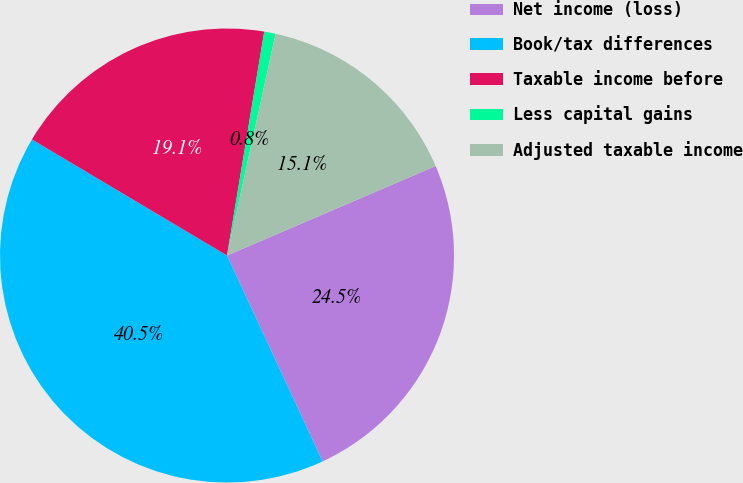Convert chart to OTSL. <chart><loc_0><loc_0><loc_500><loc_500><pie_chart><fcel>Net income (loss)<fcel>Book/tax differences<fcel>Taxable income before<fcel>Less capital gains<fcel>Adjusted taxable income<nl><fcel>24.53%<fcel>40.46%<fcel>19.08%<fcel>0.81%<fcel>15.12%<nl></chart> 